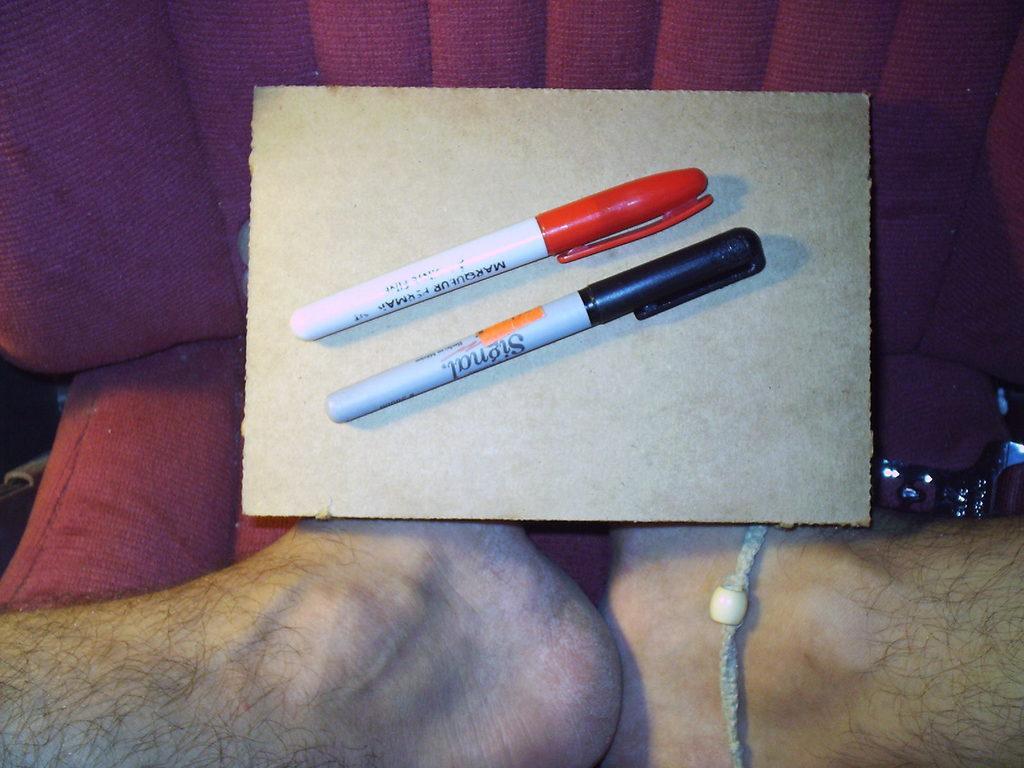Please provide a concise description of this image. In this image in the front there are legs of the person visible. In the center there are pens on the cardboard and there is a sofa which is red in colour and there is a bottle on the sofa. 